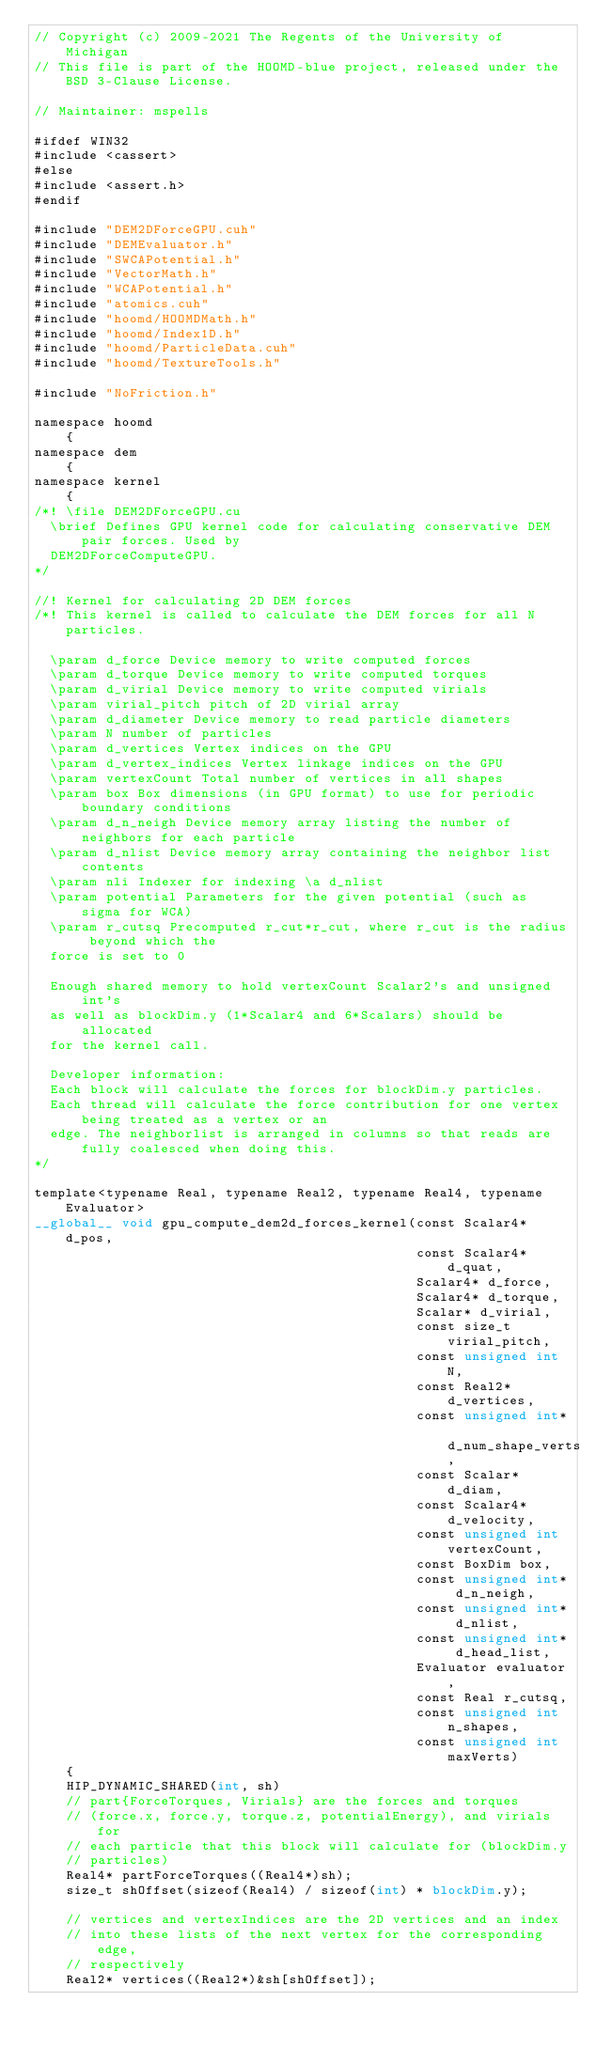<code> <loc_0><loc_0><loc_500><loc_500><_Cuda_>// Copyright (c) 2009-2021 The Regents of the University of Michigan
// This file is part of the HOOMD-blue project, released under the BSD 3-Clause License.

// Maintainer: mspells

#ifdef WIN32
#include <cassert>
#else
#include <assert.h>
#endif

#include "DEM2DForceGPU.cuh"
#include "DEMEvaluator.h"
#include "SWCAPotential.h"
#include "VectorMath.h"
#include "WCAPotential.h"
#include "atomics.cuh"
#include "hoomd/HOOMDMath.h"
#include "hoomd/Index1D.h"
#include "hoomd/ParticleData.cuh"
#include "hoomd/TextureTools.h"

#include "NoFriction.h"

namespace hoomd
    {
namespace dem
    {
namespace kernel
    {
/*! \file DEM2DForceGPU.cu
  \brief Defines GPU kernel code for calculating conservative DEM pair forces. Used by
  DEM2DForceComputeGPU.
*/

//! Kernel for calculating 2D DEM forces
/*! This kernel is called to calculate the DEM forces for all N particles.

  \param d_force Device memory to write computed forces
  \param d_torque Device memory to write computed torques
  \param d_virial Device memory to write computed virials
  \param virial_pitch pitch of 2D virial array
  \param d_diameter Device memory to read particle diameters
  \param N number of particles
  \param d_vertices Vertex indices on the GPU
  \param d_vertex_indices Vertex linkage indices on the GPU
  \param vertexCount Total number of vertices in all shapes
  \param box Box dimensions (in GPU format) to use for periodic boundary conditions
  \param d_n_neigh Device memory array listing the number of neighbors for each particle
  \param d_nlist Device memory array containing the neighbor list contents
  \param nli Indexer for indexing \a d_nlist
  \param potential Parameters for the given potential (such as sigma for WCA)
  \param r_cutsq Precomputed r_cut*r_cut, where r_cut is the radius beyond which the
  force is set to 0

  Enough shared memory to hold vertexCount Scalar2's and unsigned int's
  as well as blockDim.y (1*Scalar4 and 6*Scalars) should be allocated
  for the kernel call.

  Developer information:
  Each block will calculate the forces for blockDim.y particles.
  Each thread will calculate the force contribution for one vertex being treated as a vertex or an
  edge. The neighborlist is arranged in columns so that reads are fully coalesced when doing this.
*/

template<typename Real, typename Real2, typename Real4, typename Evaluator>
__global__ void gpu_compute_dem2d_forces_kernel(const Scalar4* d_pos,
                                                const Scalar4* d_quat,
                                                Scalar4* d_force,
                                                Scalar4* d_torque,
                                                Scalar* d_virial,
                                                const size_t virial_pitch,
                                                const unsigned int N,
                                                const Real2* d_vertices,
                                                const unsigned int* d_num_shape_verts,
                                                const Scalar* d_diam,
                                                const Scalar4* d_velocity,
                                                const unsigned int vertexCount,
                                                const BoxDim box,
                                                const unsigned int* d_n_neigh,
                                                const unsigned int* d_nlist,
                                                const unsigned int* d_head_list,
                                                Evaluator evaluator,
                                                const Real r_cutsq,
                                                const unsigned int n_shapes,
                                                const unsigned int maxVerts)
    {
    HIP_DYNAMIC_SHARED(int, sh)
    // part{ForceTorques, Virials} are the forces and torques
    // (force.x, force.y, torque.z, potentialEnergy), and virials for
    // each particle that this block will calculate for (blockDim.y
    // particles)
    Real4* partForceTorques((Real4*)sh);
    size_t shOffset(sizeof(Real4) / sizeof(int) * blockDim.y);

    // vertices and vertexIndices are the 2D vertices and an index
    // into these lists of the next vertex for the corresponding edge,
    // respectively
    Real2* vertices((Real2*)&sh[shOffset]);</code> 